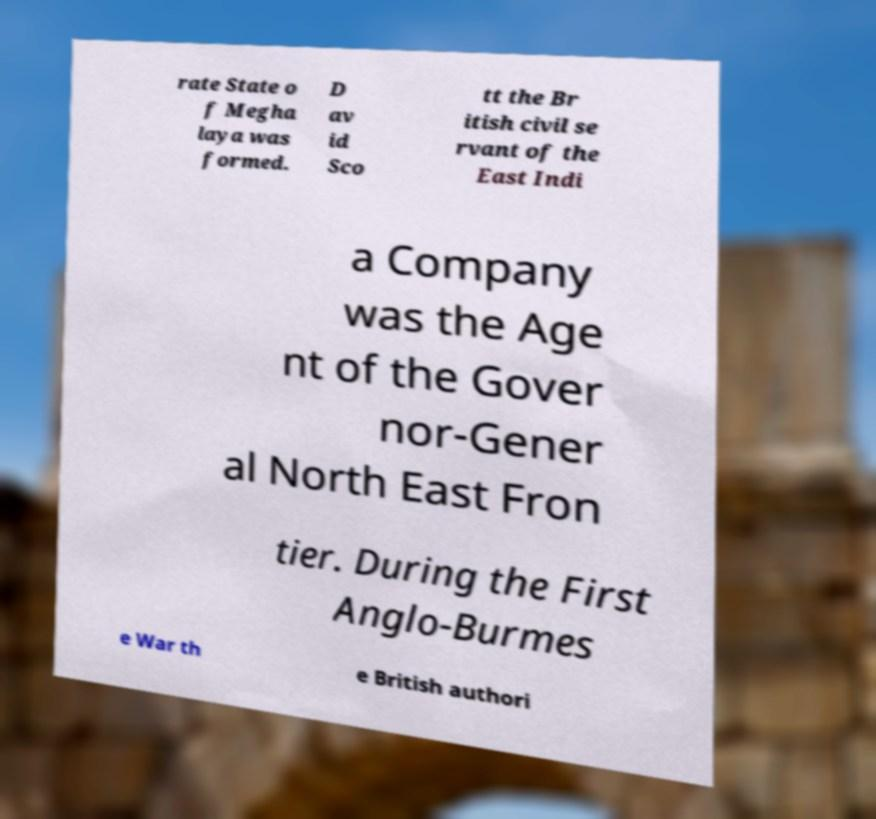Could you extract and type out the text from this image? rate State o f Megha laya was formed. D av id Sco tt the Br itish civil se rvant of the East Indi a Company was the Age nt of the Gover nor-Gener al North East Fron tier. During the First Anglo-Burmes e War th e British authori 